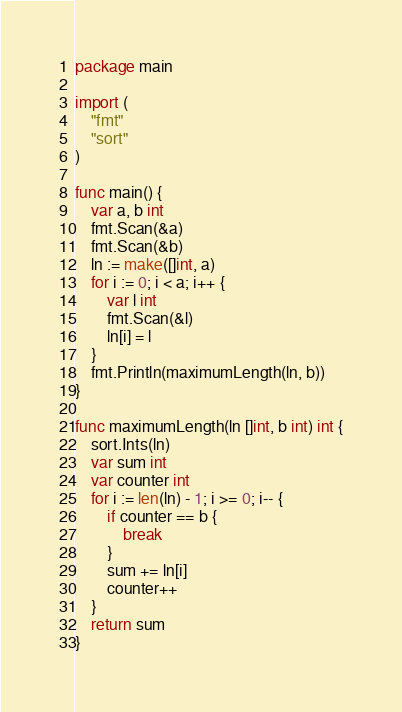<code> <loc_0><loc_0><loc_500><loc_500><_Go_>package main

import (
	"fmt"
	"sort"
)

func main() {
	var a, b int
	fmt.Scan(&a)
	fmt.Scan(&b)
	ln := make([]int, a)
	for i := 0; i < a; i++ {
		var l int
		fmt.Scan(&l)
		ln[i] = l
	}
	fmt.Println(maximumLength(ln, b))
}

func maximumLength(ln []int, b int) int {
	sort.Ints(ln)
	var sum int
	var counter int
	for i := len(ln) - 1; i >= 0; i-- {
		if counter == b {
			break
		}
		sum += ln[i]
		counter++
	}
	return sum
}
</code> 